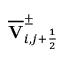<formula> <loc_0><loc_0><loc_500><loc_500>\overline { V } _ { i , j + \frac { 1 } { 2 } } ^ { \pm }</formula> 